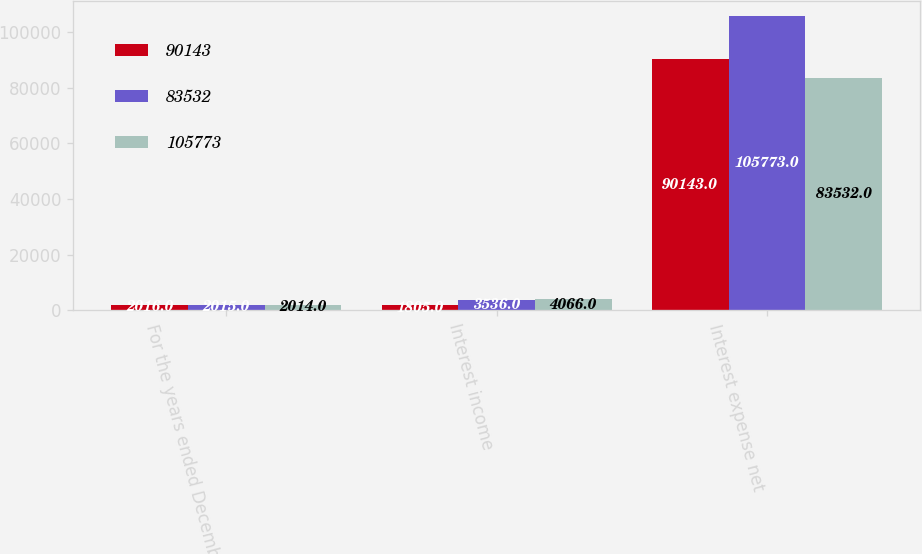<chart> <loc_0><loc_0><loc_500><loc_500><stacked_bar_chart><ecel><fcel>For the years ended December<fcel>Interest income<fcel>Interest expense net<nl><fcel>90143<fcel>2016<fcel>1805<fcel>90143<nl><fcel>83532<fcel>2015<fcel>3536<fcel>105773<nl><fcel>105773<fcel>2014<fcel>4066<fcel>83532<nl></chart> 